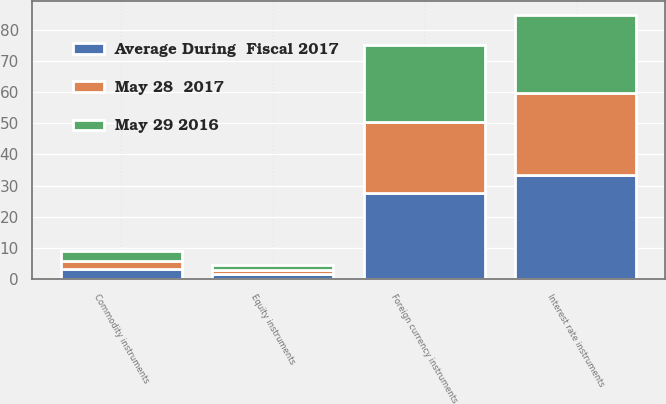Convert chart to OTSL. <chart><loc_0><loc_0><loc_500><loc_500><stacked_bar_chart><ecel><fcel>Interest rate instruments<fcel>Foreign currency instruments<fcel>Commodity instruments<fcel>Equity instruments<nl><fcel>May 29 2016<fcel>25.1<fcel>24.6<fcel>3.2<fcel>1.3<nl><fcel>May 28  2017<fcel>26.5<fcel>22.9<fcel>2.5<fcel>1.4<nl><fcel>Average During  Fiscal 2017<fcel>33.3<fcel>27.6<fcel>3.3<fcel>1.7<nl></chart> 